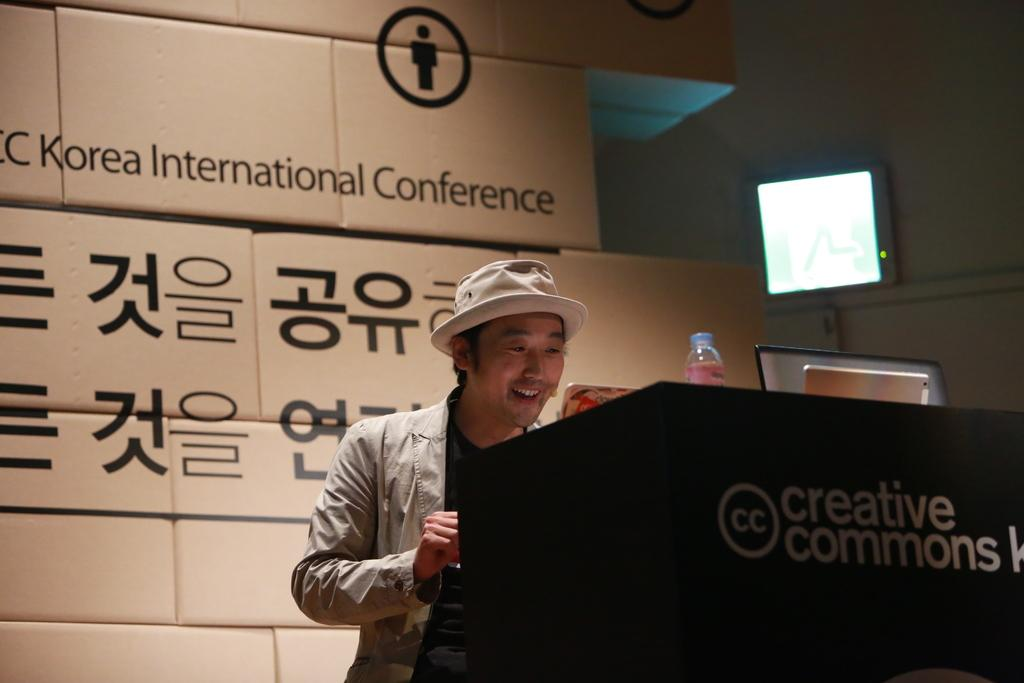Who is present in the image? There is a man in the image. What is the man's proximity to in the image? The man is near a podium. What is on the podium? There is a bottle on the podium, along with other objects. What can be seen in the background of the image? There are cardboard boxes and an object in the background of the image. What type of wilderness can be seen in the background of the image? There is no wilderness present in the image; it features a man near a podium with cardboard boxes in the background. What is the topic of the discussion taking place between the man and the bee in the image? There is no discussion or bee present in the image. 